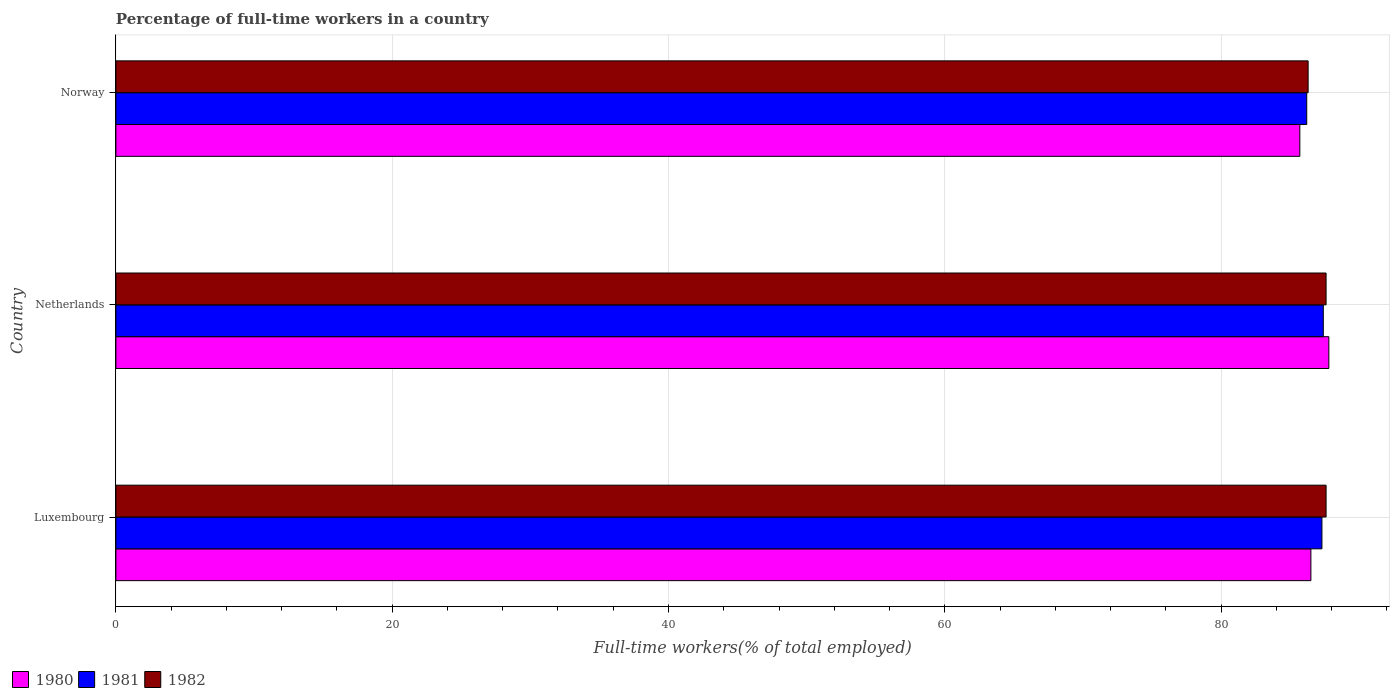How many different coloured bars are there?
Your answer should be compact. 3. How many bars are there on the 3rd tick from the bottom?
Your answer should be compact. 3. In how many cases, is the number of bars for a given country not equal to the number of legend labels?
Offer a very short reply. 0. What is the percentage of full-time workers in 1982 in Netherlands?
Your answer should be very brief. 87.6. Across all countries, what is the maximum percentage of full-time workers in 1981?
Keep it short and to the point. 87.4. Across all countries, what is the minimum percentage of full-time workers in 1980?
Give a very brief answer. 85.7. In which country was the percentage of full-time workers in 1982 maximum?
Your answer should be very brief. Luxembourg. In which country was the percentage of full-time workers in 1980 minimum?
Provide a short and direct response. Norway. What is the total percentage of full-time workers in 1980 in the graph?
Your response must be concise. 260. What is the difference between the percentage of full-time workers in 1980 in Luxembourg and that in Norway?
Your response must be concise. 0.8. What is the difference between the percentage of full-time workers in 1981 in Netherlands and the percentage of full-time workers in 1982 in Luxembourg?
Provide a short and direct response. -0.2. What is the average percentage of full-time workers in 1981 per country?
Your answer should be compact. 86.97. What is the difference between the percentage of full-time workers in 1981 and percentage of full-time workers in 1980 in Luxembourg?
Offer a very short reply. 0.8. In how many countries, is the percentage of full-time workers in 1982 greater than 20 %?
Offer a terse response. 3. What is the ratio of the percentage of full-time workers in 1980 in Luxembourg to that in Norway?
Give a very brief answer. 1.01. What is the difference between the highest and the second highest percentage of full-time workers in 1980?
Offer a very short reply. 1.3. What is the difference between the highest and the lowest percentage of full-time workers in 1982?
Your response must be concise. 1.3. Is the sum of the percentage of full-time workers in 1982 in Netherlands and Norway greater than the maximum percentage of full-time workers in 1980 across all countries?
Offer a terse response. Yes. What does the 3rd bar from the top in Norway represents?
Your answer should be compact. 1980. Is it the case that in every country, the sum of the percentage of full-time workers in 1981 and percentage of full-time workers in 1982 is greater than the percentage of full-time workers in 1980?
Keep it short and to the point. Yes. Does the graph contain any zero values?
Provide a short and direct response. No. Where does the legend appear in the graph?
Make the answer very short. Bottom left. What is the title of the graph?
Make the answer very short. Percentage of full-time workers in a country. What is the label or title of the X-axis?
Give a very brief answer. Full-time workers(% of total employed). What is the Full-time workers(% of total employed) of 1980 in Luxembourg?
Your answer should be compact. 86.5. What is the Full-time workers(% of total employed) in 1981 in Luxembourg?
Give a very brief answer. 87.3. What is the Full-time workers(% of total employed) of 1982 in Luxembourg?
Ensure brevity in your answer.  87.6. What is the Full-time workers(% of total employed) in 1980 in Netherlands?
Your answer should be compact. 87.8. What is the Full-time workers(% of total employed) of 1981 in Netherlands?
Ensure brevity in your answer.  87.4. What is the Full-time workers(% of total employed) in 1982 in Netherlands?
Make the answer very short. 87.6. What is the Full-time workers(% of total employed) of 1980 in Norway?
Your answer should be very brief. 85.7. What is the Full-time workers(% of total employed) in 1981 in Norway?
Ensure brevity in your answer.  86.2. What is the Full-time workers(% of total employed) of 1982 in Norway?
Your answer should be very brief. 86.3. Across all countries, what is the maximum Full-time workers(% of total employed) in 1980?
Offer a terse response. 87.8. Across all countries, what is the maximum Full-time workers(% of total employed) in 1981?
Your response must be concise. 87.4. Across all countries, what is the maximum Full-time workers(% of total employed) of 1982?
Provide a succinct answer. 87.6. Across all countries, what is the minimum Full-time workers(% of total employed) in 1980?
Your response must be concise. 85.7. Across all countries, what is the minimum Full-time workers(% of total employed) in 1981?
Your answer should be very brief. 86.2. Across all countries, what is the minimum Full-time workers(% of total employed) in 1982?
Your response must be concise. 86.3. What is the total Full-time workers(% of total employed) in 1980 in the graph?
Make the answer very short. 260. What is the total Full-time workers(% of total employed) of 1981 in the graph?
Make the answer very short. 260.9. What is the total Full-time workers(% of total employed) of 1982 in the graph?
Your answer should be very brief. 261.5. What is the difference between the Full-time workers(% of total employed) in 1980 in Luxembourg and that in Netherlands?
Your response must be concise. -1.3. What is the difference between the Full-time workers(% of total employed) of 1981 in Luxembourg and that in Netherlands?
Your response must be concise. -0.1. What is the difference between the Full-time workers(% of total employed) in 1981 in Luxembourg and that in Norway?
Your answer should be compact. 1.1. What is the difference between the Full-time workers(% of total employed) in 1982 in Luxembourg and that in Norway?
Ensure brevity in your answer.  1.3. What is the difference between the Full-time workers(% of total employed) of 1980 in Netherlands and that in Norway?
Give a very brief answer. 2.1. What is the difference between the Full-time workers(% of total employed) of 1982 in Netherlands and that in Norway?
Provide a succinct answer. 1.3. What is the difference between the Full-time workers(% of total employed) in 1980 in Luxembourg and the Full-time workers(% of total employed) in 1981 in Netherlands?
Offer a terse response. -0.9. What is the difference between the Full-time workers(% of total employed) of 1980 in Luxembourg and the Full-time workers(% of total employed) of 1982 in Netherlands?
Offer a terse response. -1.1. What is the difference between the Full-time workers(% of total employed) in 1980 in Luxembourg and the Full-time workers(% of total employed) in 1982 in Norway?
Make the answer very short. 0.2. What is the difference between the Full-time workers(% of total employed) of 1980 in Netherlands and the Full-time workers(% of total employed) of 1981 in Norway?
Ensure brevity in your answer.  1.6. What is the difference between the Full-time workers(% of total employed) of 1980 in Netherlands and the Full-time workers(% of total employed) of 1982 in Norway?
Make the answer very short. 1.5. What is the average Full-time workers(% of total employed) of 1980 per country?
Keep it short and to the point. 86.67. What is the average Full-time workers(% of total employed) of 1981 per country?
Your answer should be very brief. 86.97. What is the average Full-time workers(% of total employed) of 1982 per country?
Keep it short and to the point. 87.17. What is the difference between the Full-time workers(% of total employed) in 1980 and Full-time workers(% of total employed) in 1981 in Luxembourg?
Ensure brevity in your answer.  -0.8. What is the difference between the Full-time workers(% of total employed) of 1981 and Full-time workers(% of total employed) of 1982 in Luxembourg?
Your response must be concise. -0.3. What is the difference between the Full-time workers(% of total employed) in 1980 and Full-time workers(% of total employed) in 1981 in Netherlands?
Your answer should be very brief. 0.4. What is the difference between the Full-time workers(% of total employed) in 1980 and Full-time workers(% of total employed) in 1982 in Netherlands?
Make the answer very short. 0.2. What is the ratio of the Full-time workers(% of total employed) of 1980 in Luxembourg to that in Netherlands?
Your response must be concise. 0.99. What is the ratio of the Full-time workers(% of total employed) in 1981 in Luxembourg to that in Netherlands?
Offer a terse response. 1. What is the ratio of the Full-time workers(% of total employed) of 1982 in Luxembourg to that in Netherlands?
Provide a succinct answer. 1. What is the ratio of the Full-time workers(% of total employed) in 1980 in Luxembourg to that in Norway?
Your answer should be compact. 1.01. What is the ratio of the Full-time workers(% of total employed) of 1981 in Luxembourg to that in Norway?
Offer a terse response. 1.01. What is the ratio of the Full-time workers(% of total employed) of 1982 in Luxembourg to that in Norway?
Keep it short and to the point. 1.02. What is the ratio of the Full-time workers(% of total employed) in 1980 in Netherlands to that in Norway?
Keep it short and to the point. 1.02. What is the ratio of the Full-time workers(% of total employed) of 1981 in Netherlands to that in Norway?
Keep it short and to the point. 1.01. What is the ratio of the Full-time workers(% of total employed) in 1982 in Netherlands to that in Norway?
Ensure brevity in your answer.  1.02. What is the difference between the highest and the second highest Full-time workers(% of total employed) of 1980?
Your answer should be compact. 1.3. What is the difference between the highest and the lowest Full-time workers(% of total employed) of 1980?
Offer a very short reply. 2.1. 